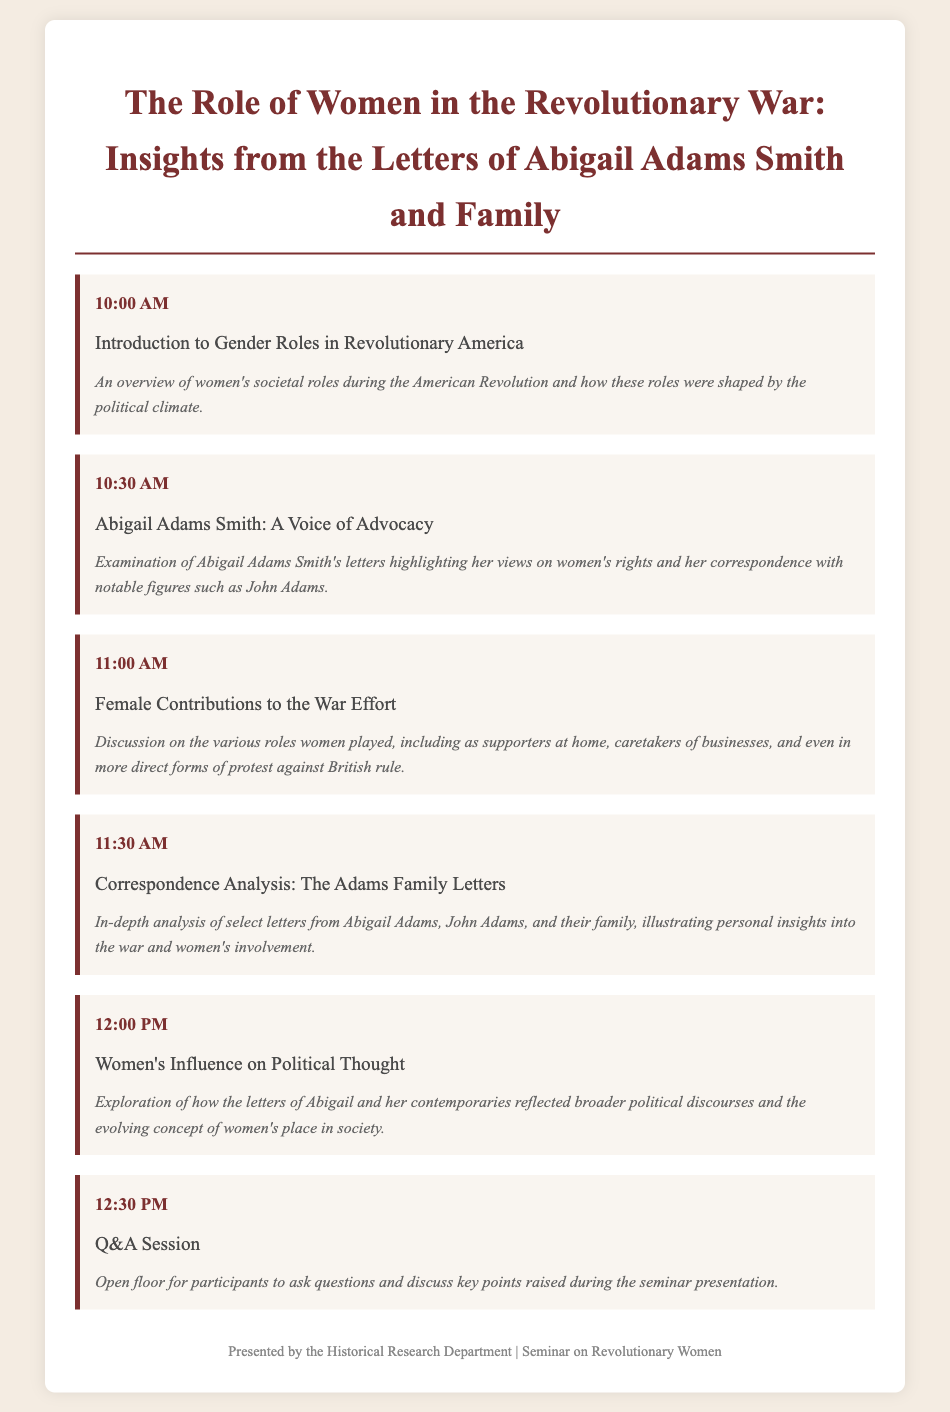What time does the seminar start? The seminar starts at 10:00 AM, as indicated in the document.
Answer: 10:00 AM Who is the focus of the second agenda item? The second agenda item focuses on Abigail Adams Smith, as mentioned in the topic.
Answer: Abigail Adams Smith What is the main topic of the third agenda item? The main topic of the third agenda item is about female contributions to the war effort during the Revolutionary War.
Answer: Female Contributions to the War Effort Which letters are analyzed in the fourth agenda item? The fourth agenda item specifically analyzes letters from Abigail Adams and John Adams.
Answer: The Adams Family Letters What is the duration of the Q&A session? The Q&A session starts at 12:30 PM and there is no specified end time, but it follows the last agenda item.
Answer: Duration not specified What role does the Historical Research Department play in the seminar? They are the presenters of the seminar, as noted in the footer.
Answer: Presented by the Historical Research Department What is the main theme of the seminar? The main theme revolves around the role of women in the Revolutionary War, derived from the letters of Abigail Adams Smith and her family.
Answer: The Role of Women in the Revolutionary War What color is used for the headings in the document? The headings use a dark red color (#7c3030) as specified in the style section of the document.
Answer: Dark red 